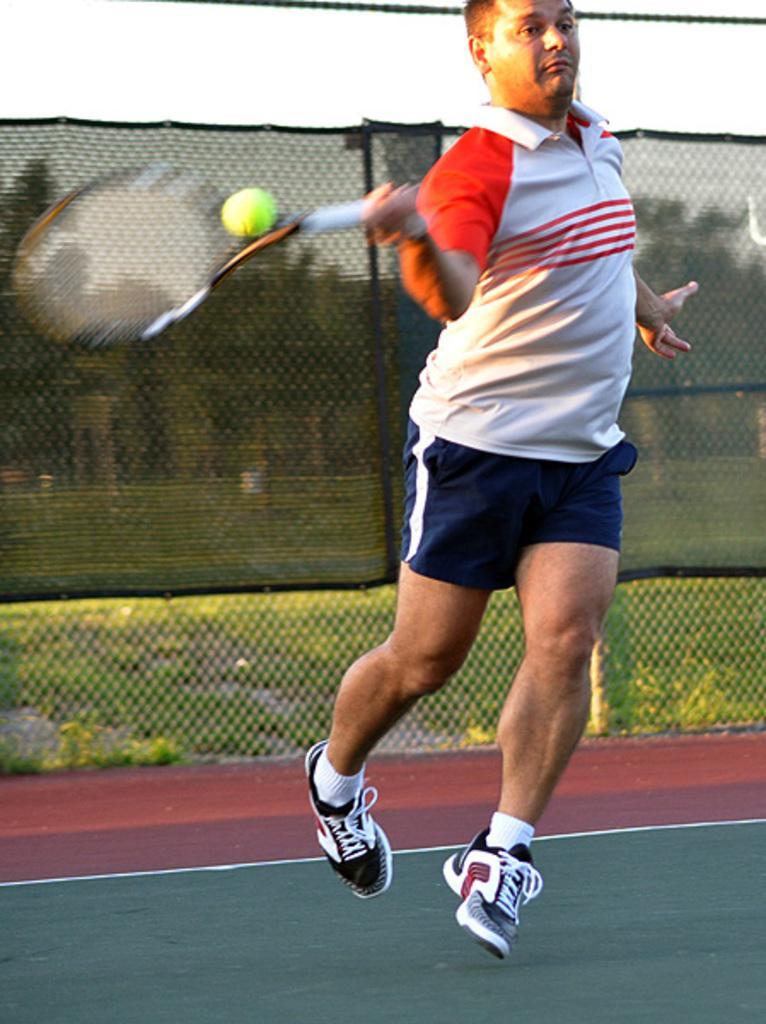Can you describe this image briefly? This image is clicked in a tennis court. There is a net in the back side. There is a person who is holding a racket. He is hitting the ball with his racket. There is sky on the top. He is wearing white color shirt and shoes. 